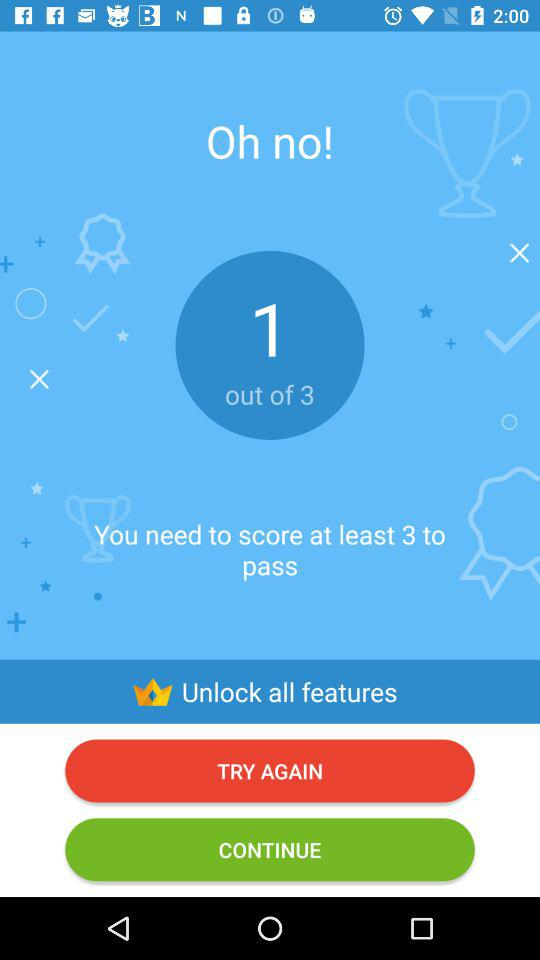How many points do you need to pass?
Answer the question using a single word or phrase. 3 